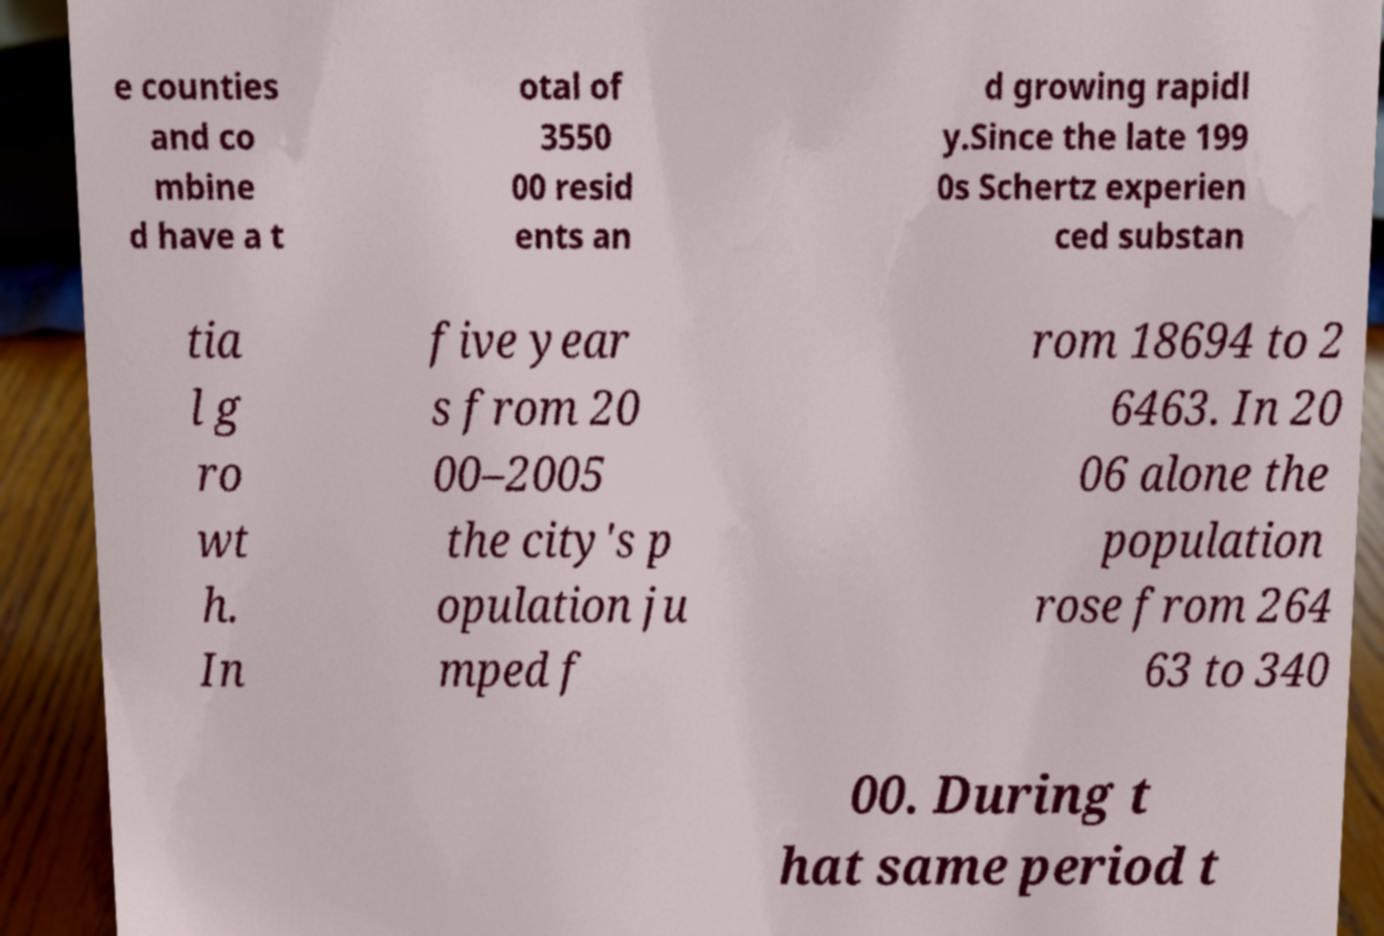Please identify and transcribe the text found in this image. e counties and co mbine d have a t otal of 3550 00 resid ents an d growing rapidl y.Since the late 199 0s Schertz experien ced substan tia l g ro wt h. In five year s from 20 00–2005 the city's p opulation ju mped f rom 18694 to 2 6463. In 20 06 alone the population rose from 264 63 to 340 00. During t hat same period t 